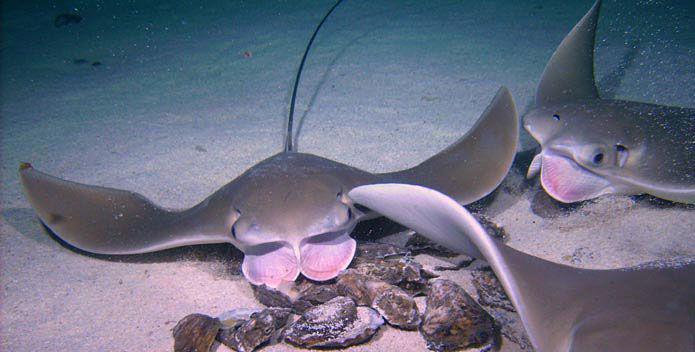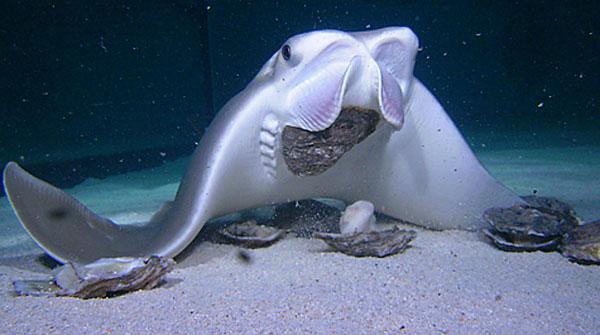The first image is the image on the left, the second image is the image on the right. Examine the images to the left and right. Is the description "One image appears to show one stingray on top of another stingray, and the other image shows at least one stingray positioned over oyster-like shells." accurate? Answer yes or no. No. 